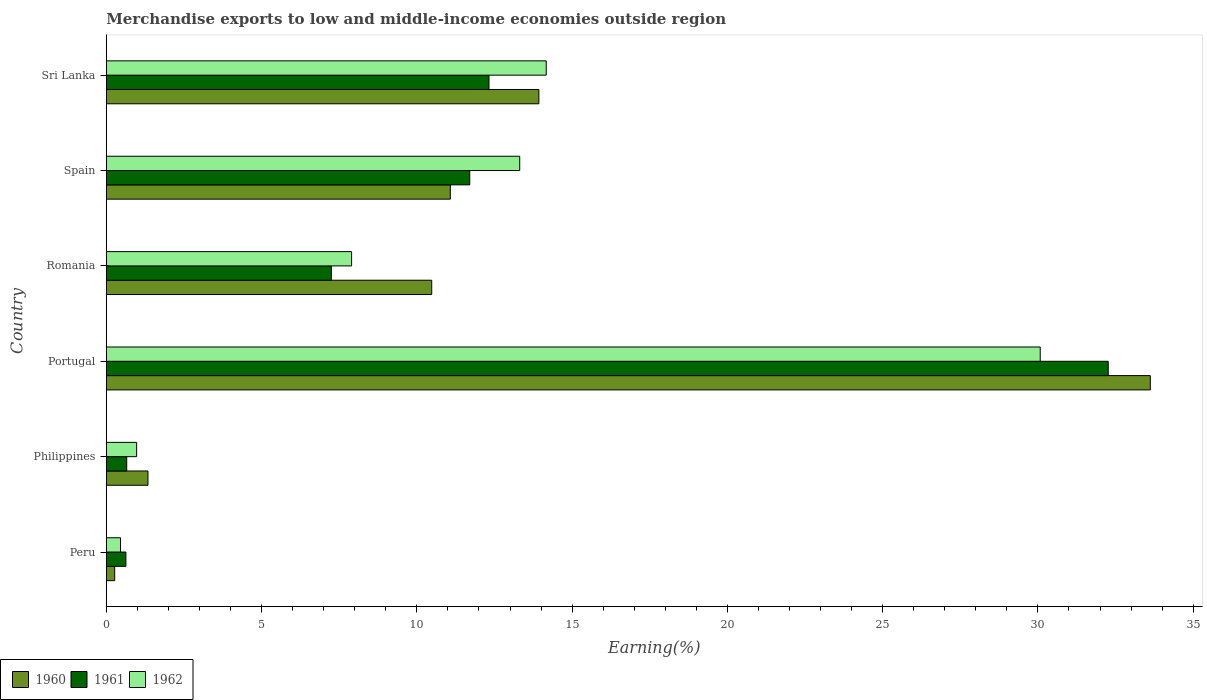How many different coloured bars are there?
Keep it short and to the point. 3. How many groups of bars are there?
Your answer should be very brief. 6. Are the number of bars per tick equal to the number of legend labels?
Offer a terse response. Yes. How many bars are there on the 3rd tick from the bottom?
Give a very brief answer. 3. What is the label of the 1st group of bars from the top?
Your response must be concise. Sri Lanka. In how many cases, is the number of bars for a given country not equal to the number of legend labels?
Your response must be concise. 0. What is the percentage of amount earned from merchandise exports in 1960 in Spain?
Offer a terse response. 11.08. Across all countries, what is the maximum percentage of amount earned from merchandise exports in 1960?
Your response must be concise. 33.62. Across all countries, what is the minimum percentage of amount earned from merchandise exports in 1961?
Provide a short and direct response. 0.63. What is the total percentage of amount earned from merchandise exports in 1962 in the graph?
Your response must be concise. 66.88. What is the difference between the percentage of amount earned from merchandise exports in 1962 in Romania and that in Spain?
Your answer should be very brief. -5.41. What is the difference between the percentage of amount earned from merchandise exports in 1962 in Peru and the percentage of amount earned from merchandise exports in 1960 in Sri Lanka?
Your response must be concise. -13.47. What is the average percentage of amount earned from merchandise exports in 1960 per country?
Provide a succinct answer. 11.79. What is the difference between the percentage of amount earned from merchandise exports in 1961 and percentage of amount earned from merchandise exports in 1962 in Philippines?
Your answer should be very brief. -0.32. In how many countries, is the percentage of amount earned from merchandise exports in 1962 greater than 28 %?
Make the answer very short. 1. What is the ratio of the percentage of amount earned from merchandise exports in 1960 in Portugal to that in Romania?
Provide a succinct answer. 3.21. Is the percentage of amount earned from merchandise exports in 1960 in Philippines less than that in Portugal?
Provide a short and direct response. Yes. Is the difference between the percentage of amount earned from merchandise exports in 1961 in Philippines and Romania greater than the difference between the percentage of amount earned from merchandise exports in 1962 in Philippines and Romania?
Ensure brevity in your answer.  Yes. What is the difference between the highest and the second highest percentage of amount earned from merchandise exports in 1960?
Your response must be concise. 19.69. What is the difference between the highest and the lowest percentage of amount earned from merchandise exports in 1961?
Provide a succinct answer. 31.63. Is the sum of the percentage of amount earned from merchandise exports in 1960 in Philippines and Romania greater than the maximum percentage of amount earned from merchandise exports in 1961 across all countries?
Provide a succinct answer. No. What does the 2nd bar from the top in Peru represents?
Ensure brevity in your answer.  1961. What does the 1st bar from the bottom in Sri Lanka represents?
Offer a very short reply. 1960. Is it the case that in every country, the sum of the percentage of amount earned from merchandise exports in 1962 and percentage of amount earned from merchandise exports in 1961 is greater than the percentage of amount earned from merchandise exports in 1960?
Provide a succinct answer. Yes. Are all the bars in the graph horizontal?
Keep it short and to the point. Yes. How many countries are there in the graph?
Provide a short and direct response. 6. What is the difference between two consecutive major ticks on the X-axis?
Give a very brief answer. 5. Where does the legend appear in the graph?
Provide a short and direct response. Bottom left. What is the title of the graph?
Your response must be concise. Merchandise exports to low and middle-income economies outside region. Does "1974" appear as one of the legend labels in the graph?
Give a very brief answer. No. What is the label or title of the X-axis?
Offer a terse response. Earning(%). What is the Earning(%) of 1960 in Peru?
Your response must be concise. 0.27. What is the Earning(%) of 1961 in Peru?
Offer a very short reply. 0.63. What is the Earning(%) of 1962 in Peru?
Offer a terse response. 0.46. What is the Earning(%) in 1960 in Philippines?
Keep it short and to the point. 1.34. What is the Earning(%) in 1961 in Philippines?
Your response must be concise. 0.66. What is the Earning(%) in 1962 in Philippines?
Offer a terse response. 0.98. What is the Earning(%) in 1960 in Portugal?
Give a very brief answer. 33.62. What is the Earning(%) of 1961 in Portugal?
Provide a short and direct response. 32.26. What is the Earning(%) in 1962 in Portugal?
Give a very brief answer. 30.07. What is the Earning(%) in 1960 in Romania?
Your answer should be compact. 10.48. What is the Earning(%) in 1961 in Romania?
Your response must be concise. 7.25. What is the Earning(%) in 1962 in Romania?
Ensure brevity in your answer.  7.9. What is the Earning(%) in 1960 in Spain?
Your answer should be very brief. 11.08. What is the Earning(%) of 1961 in Spain?
Keep it short and to the point. 11.7. What is the Earning(%) in 1962 in Spain?
Provide a succinct answer. 13.31. What is the Earning(%) of 1960 in Sri Lanka?
Your response must be concise. 13.93. What is the Earning(%) in 1961 in Sri Lanka?
Your answer should be very brief. 12.32. What is the Earning(%) in 1962 in Sri Lanka?
Your answer should be very brief. 14.17. Across all countries, what is the maximum Earning(%) in 1960?
Ensure brevity in your answer.  33.62. Across all countries, what is the maximum Earning(%) of 1961?
Provide a short and direct response. 32.26. Across all countries, what is the maximum Earning(%) in 1962?
Provide a succinct answer. 30.07. Across all countries, what is the minimum Earning(%) in 1960?
Your answer should be compact. 0.27. Across all countries, what is the minimum Earning(%) in 1961?
Your answer should be very brief. 0.63. Across all countries, what is the minimum Earning(%) of 1962?
Ensure brevity in your answer.  0.46. What is the total Earning(%) of 1960 in the graph?
Provide a short and direct response. 70.71. What is the total Earning(%) in 1961 in the graph?
Offer a terse response. 64.82. What is the total Earning(%) in 1962 in the graph?
Your answer should be very brief. 66.88. What is the difference between the Earning(%) of 1960 in Peru and that in Philippines?
Provide a short and direct response. -1.07. What is the difference between the Earning(%) in 1961 in Peru and that in Philippines?
Provide a succinct answer. -0.03. What is the difference between the Earning(%) of 1962 in Peru and that in Philippines?
Give a very brief answer. -0.52. What is the difference between the Earning(%) in 1960 in Peru and that in Portugal?
Provide a short and direct response. -33.35. What is the difference between the Earning(%) of 1961 in Peru and that in Portugal?
Keep it short and to the point. -31.63. What is the difference between the Earning(%) in 1962 in Peru and that in Portugal?
Your answer should be very brief. -29.62. What is the difference between the Earning(%) in 1960 in Peru and that in Romania?
Your response must be concise. -10.21. What is the difference between the Earning(%) of 1961 in Peru and that in Romania?
Offer a terse response. -6.62. What is the difference between the Earning(%) of 1962 in Peru and that in Romania?
Provide a short and direct response. -7.44. What is the difference between the Earning(%) of 1960 in Peru and that in Spain?
Offer a very short reply. -10.81. What is the difference between the Earning(%) in 1961 in Peru and that in Spain?
Your answer should be compact. -11.07. What is the difference between the Earning(%) in 1962 in Peru and that in Spain?
Your answer should be very brief. -12.86. What is the difference between the Earning(%) in 1960 in Peru and that in Sri Lanka?
Your answer should be very brief. -13.66. What is the difference between the Earning(%) of 1961 in Peru and that in Sri Lanka?
Give a very brief answer. -11.69. What is the difference between the Earning(%) of 1962 in Peru and that in Sri Lanka?
Your answer should be compact. -13.71. What is the difference between the Earning(%) of 1960 in Philippines and that in Portugal?
Your answer should be very brief. -32.28. What is the difference between the Earning(%) in 1961 in Philippines and that in Portugal?
Keep it short and to the point. -31.61. What is the difference between the Earning(%) of 1962 in Philippines and that in Portugal?
Ensure brevity in your answer.  -29.1. What is the difference between the Earning(%) of 1960 in Philippines and that in Romania?
Your answer should be compact. -9.14. What is the difference between the Earning(%) of 1961 in Philippines and that in Romania?
Your response must be concise. -6.59. What is the difference between the Earning(%) in 1962 in Philippines and that in Romania?
Provide a succinct answer. -6.92. What is the difference between the Earning(%) in 1960 in Philippines and that in Spain?
Your response must be concise. -9.74. What is the difference between the Earning(%) in 1961 in Philippines and that in Spain?
Offer a terse response. -11.05. What is the difference between the Earning(%) in 1962 in Philippines and that in Spain?
Your answer should be compact. -12.34. What is the difference between the Earning(%) of 1960 in Philippines and that in Sri Lanka?
Your response must be concise. -12.59. What is the difference between the Earning(%) of 1961 in Philippines and that in Sri Lanka?
Your answer should be very brief. -11.67. What is the difference between the Earning(%) of 1962 in Philippines and that in Sri Lanka?
Provide a succinct answer. -13.19. What is the difference between the Earning(%) in 1960 in Portugal and that in Romania?
Provide a short and direct response. 23.14. What is the difference between the Earning(%) in 1961 in Portugal and that in Romania?
Your answer should be very brief. 25.02. What is the difference between the Earning(%) in 1962 in Portugal and that in Romania?
Offer a very short reply. 22.18. What is the difference between the Earning(%) in 1960 in Portugal and that in Spain?
Your answer should be compact. 22.54. What is the difference between the Earning(%) in 1961 in Portugal and that in Spain?
Provide a succinct answer. 20.56. What is the difference between the Earning(%) in 1962 in Portugal and that in Spain?
Ensure brevity in your answer.  16.76. What is the difference between the Earning(%) of 1960 in Portugal and that in Sri Lanka?
Offer a terse response. 19.69. What is the difference between the Earning(%) in 1961 in Portugal and that in Sri Lanka?
Your answer should be very brief. 19.94. What is the difference between the Earning(%) of 1962 in Portugal and that in Sri Lanka?
Keep it short and to the point. 15.91. What is the difference between the Earning(%) of 1960 in Romania and that in Spain?
Your response must be concise. -0.6. What is the difference between the Earning(%) of 1961 in Romania and that in Spain?
Make the answer very short. -4.46. What is the difference between the Earning(%) in 1962 in Romania and that in Spain?
Offer a very short reply. -5.41. What is the difference between the Earning(%) in 1960 in Romania and that in Sri Lanka?
Offer a terse response. -3.45. What is the difference between the Earning(%) in 1961 in Romania and that in Sri Lanka?
Your response must be concise. -5.08. What is the difference between the Earning(%) of 1962 in Romania and that in Sri Lanka?
Make the answer very short. -6.27. What is the difference between the Earning(%) of 1960 in Spain and that in Sri Lanka?
Give a very brief answer. -2.85. What is the difference between the Earning(%) of 1961 in Spain and that in Sri Lanka?
Your answer should be very brief. -0.62. What is the difference between the Earning(%) in 1962 in Spain and that in Sri Lanka?
Keep it short and to the point. -0.85. What is the difference between the Earning(%) of 1960 in Peru and the Earning(%) of 1961 in Philippines?
Your answer should be compact. -0.39. What is the difference between the Earning(%) of 1960 in Peru and the Earning(%) of 1962 in Philippines?
Your answer should be compact. -0.71. What is the difference between the Earning(%) of 1961 in Peru and the Earning(%) of 1962 in Philippines?
Keep it short and to the point. -0.35. What is the difference between the Earning(%) in 1960 in Peru and the Earning(%) in 1961 in Portugal?
Keep it short and to the point. -32. What is the difference between the Earning(%) of 1960 in Peru and the Earning(%) of 1962 in Portugal?
Your answer should be compact. -29.81. What is the difference between the Earning(%) in 1961 in Peru and the Earning(%) in 1962 in Portugal?
Provide a succinct answer. -29.44. What is the difference between the Earning(%) in 1960 in Peru and the Earning(%) in 1961 in Romania?
Your response must be concise. -6.98. What is the difference between the Earning(%) in 1960 in Peru and the Earning(%) in 1962 in Romania?
Ensure brevity in your answer.  -7.63. What is the difference between the Earning(%) in 1961 in Peru and the Earning(%) in 1962 in Romania?
Your response must be concise. -7.27. What is the difference between the Earning(%) of 1960 in Peru and the Earning(%) of 1961 in Spain?
Offer a very short reply. -11.43. What is the difference between the Earning(%) in 1960 in Peru and the Earning(%) in 1962 in Spain?
Your answer should be compact. -13.04. What is the difference between the Earning(%) in 1961 in Peru and the Earning(%) in 1962 in Spain?
Ensure brevity in your answer.  -12.68. What is the difference between the Earning(%) in 1960 in Peru and the Earning(%) in 1961 in Sri Lanka?
Offer a terse response. -12.05. What is the difference between the Earning(%) of 1960 in Peru and the Earning(%) of 1962 in Sri Lanka?
Provide a succinct answer. -13.9. What is the difference between the Earning(%) of 1961 in Peru and the Earning(%) of 1962 in Sri Lanka?
Your response must be concise. -13.54. What is the difference between the Earning(%) in 1960 in Philippines and the Earning(%) in 1961 in Portugal?
Keep it short and to the point. -30.92. What is the difference between the Earning(%) in 1960 in Philippines and the Earning(%) in 1962 in Portugal?
Your answer should be compact. -28.73. What is the difference between the Earning(%) of 1961 in Philippines and the Earning(%) of 1962 in Portugal?
Your answer should be compact. -29.42. What is the difference between the Earning(%) in 1960 in Philippines and the Earning(%) in 1961 in Romania?
Ensure brevity in your answer.  -5.91. What is the difference between the Earning(%) in 1960 in Philippines and the Earning(%) in 1962 in Romania?
Your answer should be compact. -6.56. What is the difference between the Earning(%) of 1961 in Philippines and the Earning(%) of 1962 in Romania?
Your answer should be compact. -7.24. What is the difference between the Earning(%) in 1960 in Philippines and the Earning(%) in 1961 in Spain?
Give a very brief answer. -10.36. What is the difference between the Earning(%) of 1960 in Philippines and the Earning(%) of 1962 in Spain?
Offer a very short reply. -11.97. What is the difference between the Earning(%) in 1961 in Philippines and the Earning(%) in 1962 in Spain?
Offer a very short reply. -12.66. What is the difference between the Earning(%) of 1960 in Philippines and the Earning(%) of 1961 in Sri Lanka?
Your answer should be very brief. -10.98. What is the difference between the Earning(%) in 1960 in Philippines and the Earning(%) in 1962 in Sri Lanka?
Provide a succinct answer. -12.83. What is the difference between the Earning(%) in 1961 in Philippines and the Earning(%) in 1962 in Sri Lanka?
Give a very brief answer. -13.51. What is the difference between the Earning(%) of 1960 in Portugal and the Earning(%) of 1961 in Romania?
Provide a short and direct response. 26.37. What is the difference between the Earning(%) of 1960 in Portugal and the Earning(%) of 1962 in Romania?
Ensure brevity in your answer.  25.72. What is the difference between the Earning(%) of 1961 in Portugal and the Earning(%) of 1962 in Romania?
Provide a succinct answer. 24.37. What is the difference between the Earning(%) in 1960 in Portugal and the Earning(%) in 1961 in Spain?
Keep it short and to the point. 21.92. What is the difference between the Earning(%) in 1960 in Portugal and the Earning(%) in 1962 in Spain?
Give a very brief answer. 20.31. What is the difference between the Earning(%) of 1961 in Portugal and the Earning(%) of 1962 in Spain?
Your answer should be compact. 18.95. What is the difference between the Earning(%) of 1960 in Portugal and the Earning(%) of 1961 in Sri Lanka?
Your answer should be compact. 21.3. What is the difference between the Earning(%) of 1960 in Portugal and the Earning(%) of 1962 in Sri Lanka?
Provide a succinct answer. 19.45. What is the difference between the Earning(%) of 1961 in Portugal and the Earning(%) of 1962 in Sri Lanka?
Keep it short and to the point. 18.1. What is the difference between the Earning(%) in 1960 in Romania and the Earning(%) in 1961 in Spain?
Provide a succinct answer. -1.23. What is the difference between the Earning(%) in 1960 in Romania and the Earning(%) in 1962 in Spain?
Provide a succinct answer. -2.83. What is the difference between the Earning(%) of 1961 in Romania and the Earning(%) of 1962 in Spain?
Ensure brevity in your answer.  -6.07. What is the difference between the Earning(%) in 1960 in Romania and the Earning(%) in 1961 in Sri Lanka?
Provide a short and direct response. -1.84. What is the difference between the Earning(%) of 1960 in Romania and the Earning(%) of 1962 in Sri Lanka?
Offer a very short reply. -3.69. What is the difference between the Earning(%) of 1961 in Romania and the Earning(%) of 1962 in Sri Lanka?
Make the answer very short. -6.92. What is the difference between the Earning(%) of 1960 in Spain and the Earning(%) of 1961 in Sri Lanka?
Provide a succinct answer. -1.25. What is the difference between the Earning(%) in 1960 in Spain and the Earning(%) in 1962 in Sri Lanka?
Offer a terse response. -3.09. What is the difference between the Earning(%) of 1961 in Spain and the Earning(%) of 1962 in Sri Lanka?
Give a very brief answer. -2.46. What is the average Earning(%) in 1960 per country?
Keep it short and to the point. 11.79. What is the average Earning(%) in 1961 per country?
Offer a very short reply. 10.8. What is the average Earning(%) of 1962 per country?
Offer a terse response. 11.15. What is the difference between the Earning(%) of 1960 and Earning(%) of 1961 in Peru?
Make the answer very short. -0.36. What is the difference between the Earning(%) in 1960 and Earning(%) in 1962 in Peru?
Offer a terse response. -0.19. What is the difference between the Earning(%) in 1961 and Earning(%) in 1962 in Peru?
Your response must be concise. 0.17. What is the difference between the Earning(%) in 1960 and Earning(%) in 1961 in Philippines?
Offer a terse response. 0.68. What is the difference between the Earning(%) in 1960 and Earning(%) in 1962 in Philippines?
Provide a short and direct response. 0.36. What is the difference between the Earning(%) in 1961 and Earning(%) in 1962 in Philippines?
Your answer should be very brief. -0.32. What is the difference between the Earning(%) in 1960 and Earning(%) in 1961 in Portugal?
Make the answer very short. 1.36. What is the difference between the Earning(%) of 1960 and Earning(%) of 1962 in Portugal?
Make the answer very short. 3.54. What is the difference between the Earning(%) in 1961 and Earning(%) in 1962 in Portugal?
Ensure brevity in your answer.  2.19. What is the difference between the Earning(%) of 1960 and Earning(%) of 1961 in Romania?
Make the answer very short. 3.23. What is the difference between the Earning(%) of 1960 and Earning(%) of 1962 in Romania?
Offer a terse response. 2.58. What is the difference between the Earning(%) of 1961 and Earning(%) of 1962 in Romania?
Ensure brevity in your answer.  -0.65. What is the difference between the Earning(%) of 1960 and Earning(%) of 1961 in Spain?
Your answer should be compact. -0.63. What is the difference between the Earning(%) in 1960 and Earning(%) in 1962 in Spain?
Your answer should be compact. -2.24. What is the difference between the Earning(%) in 1961 and Earning(%) in 1962 in Spain?
Ensure brevity in your answer.  -1.61. What is the difference between the Earning(%) of 1960 and Earning(%) of 1961 in Sri Lanka?
Give a very brief answer. 1.61. What is the difference between the Earning(%) of 1960 and Earning(%) of 1962 in Sri Lanka?
Provide a short and direct response. -0.24. What is the difference between the Earning(%) of 1961 and Earning(%) of 1962 in Sri Lanka?
Your response must be concise. -1.84. What is the ratio of the Earning(%) of 1960 in Peru to that in Philippines?
Provide a succinct answer. 0.2. What is the ratio of the Earning(%) of 1961 in Peru to that in Philippines?
Offer a terse response. 0.96. What is the ratio of the Earning(%) of 1962 in Peru to that in Philippines?
Provide a succinct answer. 0.47. What is the ratio of the Earning(%) of 1960 in Peru to that in Portugal?
Provide a succinct answer. 0.01. What is the ratio of the Earning(%) of 1961 in Peru to that in Portugal?
Offer a very short reply. 0.02. What is the ratio of the Earning(%) in 1962 in Peru to that in Portugal?
Your answer should be compact. 0.02. What is the ratio of the Earning(%) of 1960 in Peru to that in Romania?
Your response must be concise. 0.03. What is the ratio of the Earning(%) of 1961 in Peru to that in Romania?
Your answer should be compact. 0.09. What is the ratio of the Earning(%) in 1962 in Peru to that in Romania?
Your response must be concise. 0.06. What is the ratio of the Earning(%) of 1960 in Peru to that in Spain?
Provide a short and direct response. 0.02. What is the ratio of the Earning(%) in 1961 in Peru to that in Spain?
Provide a short and direct response. 0.05. What is the ratio of the Earning(%) of 1962 in Peru to that in Spain?
Ensure brevity in your answer.  0.03. What is the ratio of the Earning(%) in 1960 in Peru to that in Sri Lanka?
Offer a terse response. 0.02. What is the ratio of the Earning(%) in 1961 in Peru to that in Sri Lanka?
Provide a succinct answer. 0.05. What is the ratio of the Earning(%) of 1962 in Peru to that in Sri Lanka?
Your answer should be compact. 0.03. What is the ratio of the Earning(%) in 1960 in Philippines to that in Portugal?
Provide a short and direct response. 0.04. What is the ratio of the Earning(%) of 1961 in Philippines to that in Portugal?
Your response must be concise. 0.02. What is the ratio of the Earning(%) of 1962 in Philippines to that in Portugal?
Keep it short and to the point. 0.03. What is the ratio of the Earning(%) in 1960 in Philippines to that in Romania?
Provide a succinct answer. 0.13. What is the ratio of the Earning(%) in 1961 in Philippines to that in Romania?
Offer a terse response. 0.09. What is the ratio of the Earning(%) of 1962 in Philippines to that in Romania?
Ensure brevity in your answer.  0.12. What is the ratio of the Earning(%) of 1960 in Philippines to that in Spain?
Your answer should be very brief. 0.12. What is the ratio of the Earning(%) in 1961 in Philippines to that in Spain?
Offer a terse response. 0.06. What is the ratio of the Earning(%) in 1962 in Philippines to that in Spain?
Offer a very short reply. 0.07. What is the ratio of the Earning(%) of 1960 in Philippines to that in Sri Lanka?
Provide a short and direct response. 0.1. What is the ratio of the Earning(%) of 1961 in Philippines to that in Sri Lanka?
Ensure brevity in your answer.  0.05. What is the ratio of the Earning(%) of 1962 in Philippines to that in Sri Lanka?
Make the answer very short. 0.07. What is the ratio of the Earning(%) of 1960 in Portugal to that in Romania?
Offer a terse response. 3.21. What is the ratio of the Earning(%) in 1961 in Portugal to that in Romania?
Give a very brief answer. 4.45. What is the ratio of the Earning(%) of 1962 in Portugal to that in Romania?
Give a very brief answer. 3.81. What is the ratio of the Earning(%) in 1960 in Portugal to that in Spain?
Give a very brief answer. 3.03. What is the ratio of the Earning(%) in 1961 in Portugal to that in Spain?
Provide a short and direct response. 2.76. What is the ratio of the Earning(%) in 1962 in Portugal to that in Spain?
Ensure brevity in your answer.  2.26. What is the ratio of the Earning(%) in 1960 in Portugal to that in Sri Lanka?
Provide a short and direct response. 2.41. What is the ratio of the Earning(%) in 1961 in Portugal to that in Sri Lanka?
Offer a very short reply. 2.62. What is the ratio of the Earning(%) in 1962 in Portugal to that in Sri Lanka?
Provide a short and direct response. 2.12. What is the ratio of the Earning(%) of 1960 in Romania to that in Spain?
Make the answer very short. 0.95. What is the ratio of the Earning(%) in 1961 in Romania to that in Spain?
Keep it short and to the point. 0.62. What is the ratio of the Earning(%) in 1962 in Romania to that in Spain?
Your response must be concise. 0.59. What is the ratio of the Earning(%) of 1960 in Romania to that in Sri Lanka?
Your response must be concise. 0.75. What is the ratio of the Earning(%) of 1961 in Romania to that in Sri Lanka?
Give a very brief answer. 0.59. What is the ratio of the Earning(%) in 1962 in Romania to that in Sri Lanka?
Provide a short and direct response. 0.56. What is the ratio of the Earning(%) in 1960 in Spain to that in Sri Lanka?
Your response must be concise. 0.8. What is the ratio of the Earning(%) in 1961 in Spain to that in Sri Lanka?
Ensure brevity in your answer.  0.95. What is the ratio of the Earning(%) of 1962 in Spain to that in Sri Lanka?
Your answer should be compact. 0.94. What is the difference between the highest and the second highest Earning(%) in 1960?
Your answer should be very brief. 19.69. What is the difference between the highest and the second highest Earning(%) of 1961?
Provide a short and direct response. 19.94. What is the difference between the highest and the second highest Earning(%) of 1962?
Give a very brief answer. 15.91. What is the difference between the highest and the lowest Earning(%) in 1960?
Offer a terse response. 33.35. What is the difference between the highest and the lowest Earning(%) in 1961?
Provide a short and direct response. 31.63. What is the difference between the highest and the lowest Earning(%) in 1962?
Keep it short and to the point. 29.62. 